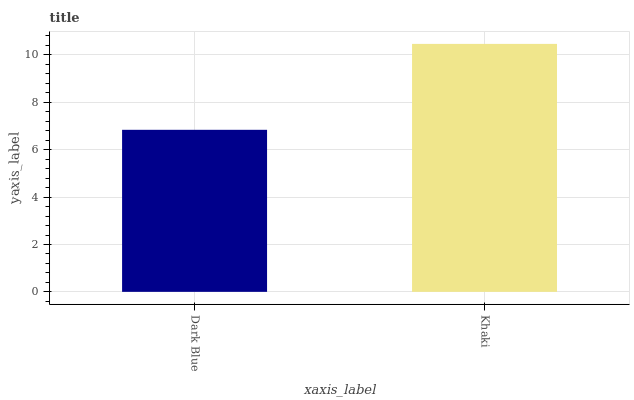Is Dark Blue the minimum?
Answer yes or no. Yes. Is Khaki the maximum?
Answer yes or no. Yes. Is Khaki the minimum?
Answer yes or no. No. Is Khaki greater than Dark Blue?
Answer yes or no. Yes. Is Dark Blue less than Khaki?
Answer yes or no. Yes. Is Dark Blue greater than Khaki?
Answer yes or no. No. Is Khaki less than Dark Blue?
Answer yes or no. No. Is Khaki the high median?
Answer yes or no. Yes. Is Dark Blue the low median?
Answer yes or no. Yes. Is Dark Blue the high median?
Answer yes or no. No. Is Khaki the low median?
Answer yes or no. No. 